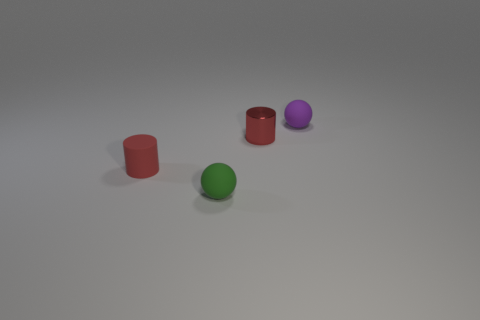Add 1 big red metallic cylinders. How many objects exist? 5 Subtract all purple balls. How many balls are left? 1 Subtract all yellow cylinders. Subtract all brown spheres. How many cylinders are left? 2 Subtract all rubber balls. Subtract all small metal objects. How many objects are left? 1 Add 2 tiny green objects. How many tiny green objects are left? 3 Add 4 tiny metal blocks. How many tiny metal blocks exist? 4 Subtract 0 yellow cylinders. How many objects are left? 4 Subtract 2 balls. How many balls are left? 0 